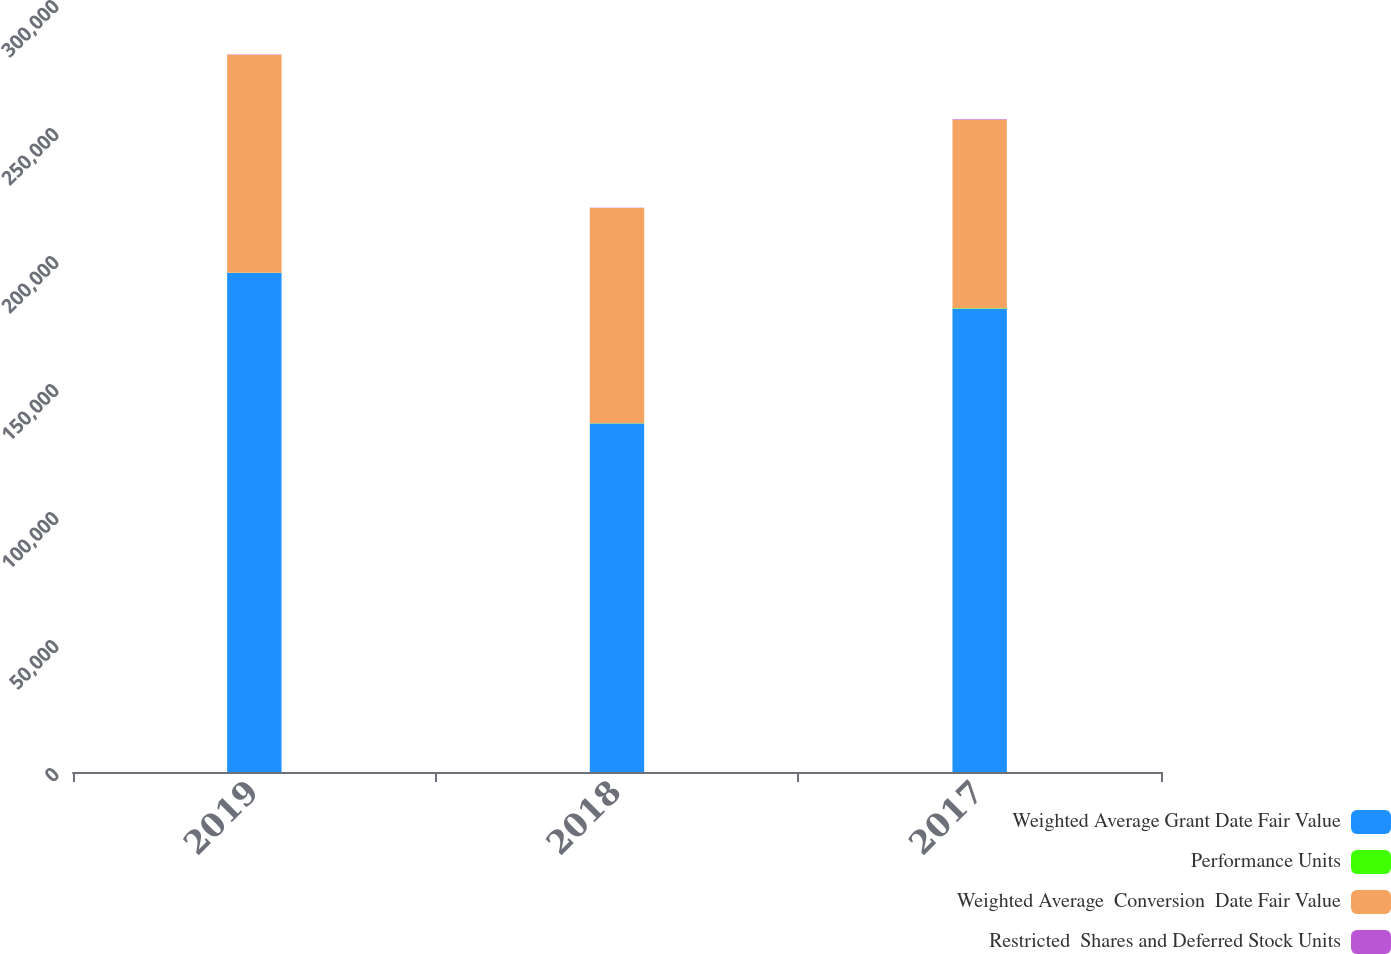Convert chart. <chart><loc_0><loc_0><loc_500><loc_500><stacked_bar_chart><ecel><fcel>2019<fcel>2018<fcel>2017<nl><fcel>Weighted Average Grant Date Fair Value<fcel>194932<fcel>136127<fcel>180997<nl><fcel>Performance Units<fcel>104.33<fcel>126.8<fcel>133.92<nl><fcel>Weighted Average  Conversion  Date Fair Value<fcel>85154<fcel>84051<fcel>73701<nl><fcel>Restricted  Shares and Deferred Stock Units<fcel>123.68<fcel>103.86<fcel>126.8<nl></chart> 